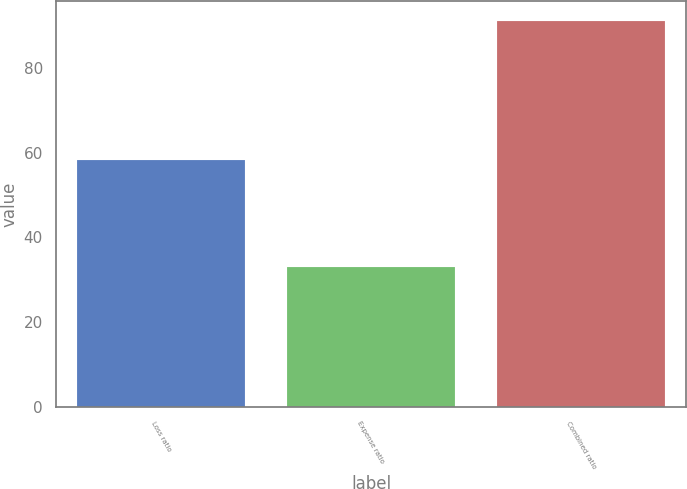<chart> <loc_0><loc_0><loc_500><loc_500><bar_chart><fcel>Loss ratio<fcel>Expense ratio<fcel>Combined ratio<nl><fcel>58.3<fcel>32.9<fcel>91.2<nl></chart> 